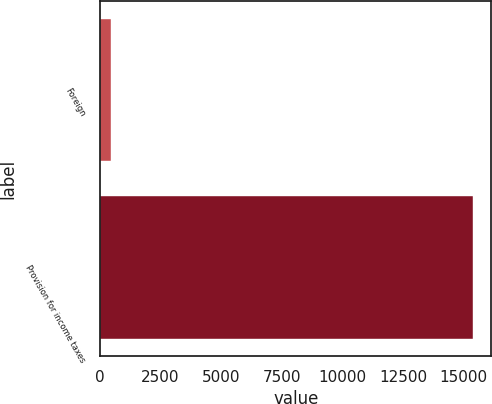Convert chart. <chart><loc_0><loc_0><loc_500><loc_500><bar_chart><fcel>Foreign<fcel>Provision for income taxes<nl><fcel>438<fcel>15378<nl></chart> 